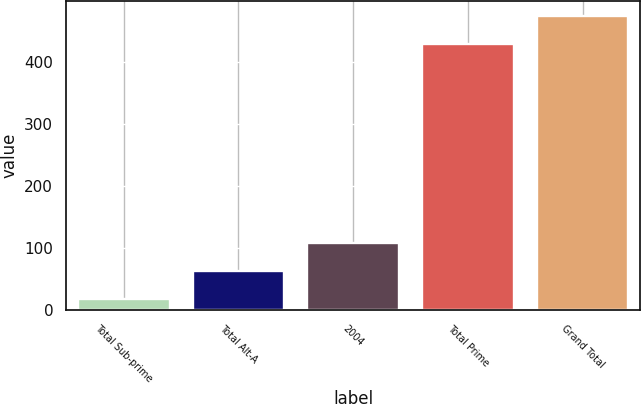<chart> <loc_0><loc_0><loc_500><loc_500><bar_chart><fcel>Total Sub-prime<fcel>Total Alt-A<fcel>2004<fcel>Total Prime<fcel>Grand Total<nl><fcel>18<fcel>62.9<fcel>107.8<fcel>429<fcel>473.9<nl></chart> 